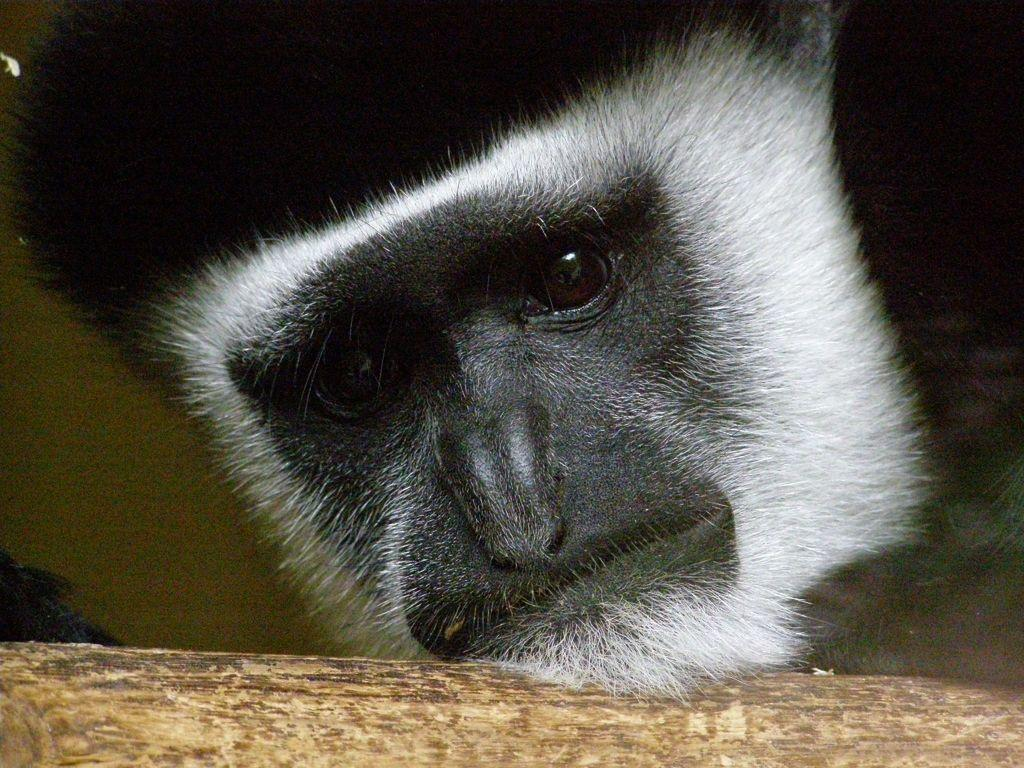What type of animal is in the picture? There is a monkey in the picture. What colors can be seen on the monkey? The monkey is white and black in color. What can be seen at the bottom of the image? There is a brown object at the bottom of the image. What time does the monkey indicate in the image? The image does not show a clock or any indication of time, so it cannot be determined what time the monkey might represent. 